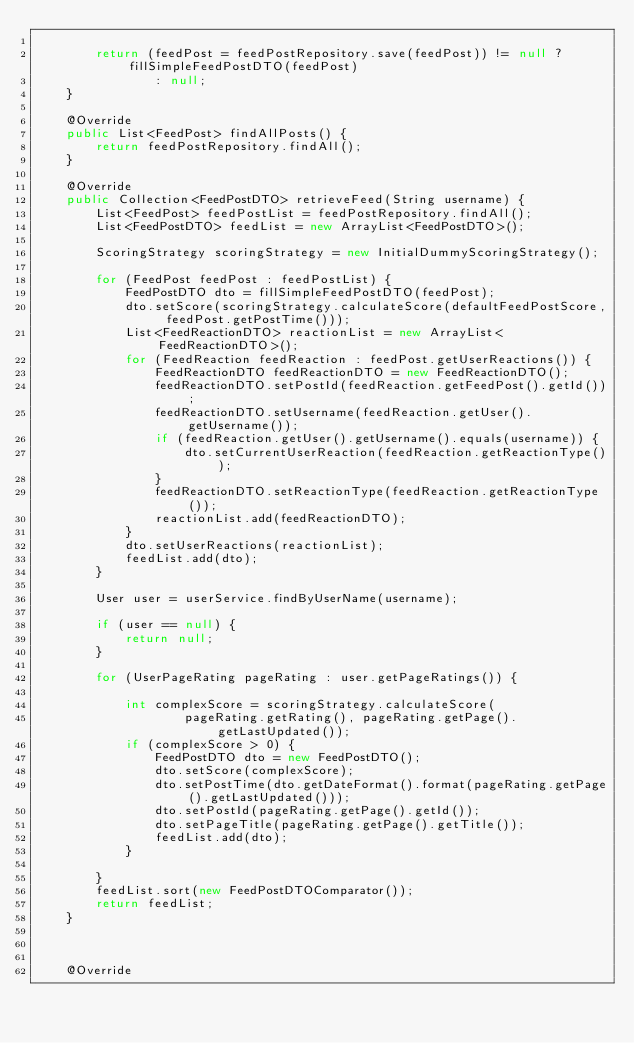<code> <loc_0><loc_0><loc_500><loc_500><_Java_>
        return (feedPost = feedPostRepository.save(feedPost)) != null ? fillSimpleFeedPostDTO(feedPost)
                : null;
    }

    @Override
    public List<FeedPost> findAllPosts() {
        return feedPostRepository.findAll();
    }

    @Override
    public Collection<FeedPostDTO> retrieveFeed(String username) {
        List<FeedPost> feedPostList = feedPostRepository.findAll();
        List<FeedPostDTO> feedList = new ArrayList<FeedPostDTO>();

        ScoringStrategy scoringStrategy = new InitialDummyScoringStrategy();

        for (FeedPost feedPost : feedPostList) {
            FeedPostDTO dto = fillSimpleFeedPostDTO(feedPost);
            dto.setScore(scoringStrategy.calculateScore(defaultFeedPostScore, feedPost.getPostTime()));
            List<FeedReactionDTO> reactionList = new ArrayList<FeedReactionDTO>();
            for (FeedReaction feedReaction : feedPost.getUserReactions()) {
                FeedReactionDTO feedReactionDTO = new FeedReactionDTO();
                feedReactionDTO.setPostId(feedReaction.getFeedPost().getId());
                feedReactionDTO.setUsername(feedReaction.getUser().getUsername());
                if (feedReaction.getUser().getUsername().equals(username)) {
                    dto.setCurrentUserReaction(feedReaction.getReactionType());
                }
                feedReactionDTO.setReactionType(feedReaction.getReactionType());
                reactionList.add(feedReactionDTO);
            }
            dto.setUserReactions(reactionList);
            feedList.add(dto);
        }

        User user = userService.findByUserName(username);

        if (user == null) {
            return null;
        }

        for (UserPageRating pageRating : user.getPageRatings()) {

            int complexScore = scoringStrategy.calculateScore(
                    pageRating.getRating(), pageRating.getPage().getLastUpdated());
            if (complexScore > 0) {
                FeedPostDTO dto = new FeedPostDTO();
                dto.setScore(complexScore);
                dto.setPostTime(dto.getDateFormat().format(pageRating.getPage().getLastUpdated()));
                dto.setPostId(pageRating.getPage().getId());
                dto.setPageTitle(pageRating.getPage().getTitle());
                feedList.add(dto);
            }

        }
        feedList.sort(new FeedPostDTOComparator());
        return feedList;
    }



    @Override</code> 